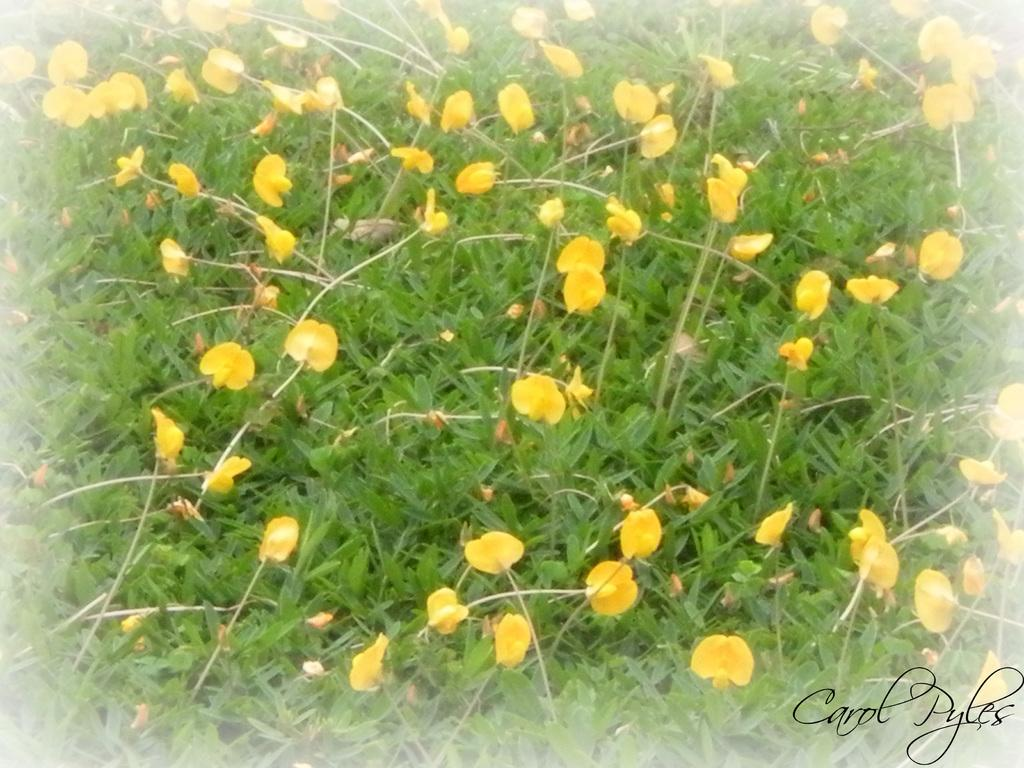What type of living organisms can be seen in the image? There are flowers and plants visible in the image. Can you describe the watermark in the image? Yes, there is a watermark at the right bottom of the image. What type of sack can be seen hanging from the flowers in the image? There is no sack present in the image, and the flowers are not hanging from anything. What experience can be gained from observing the plants in the image? The image does not convey any specific experience, as it is a static representation of flowers and plants. 